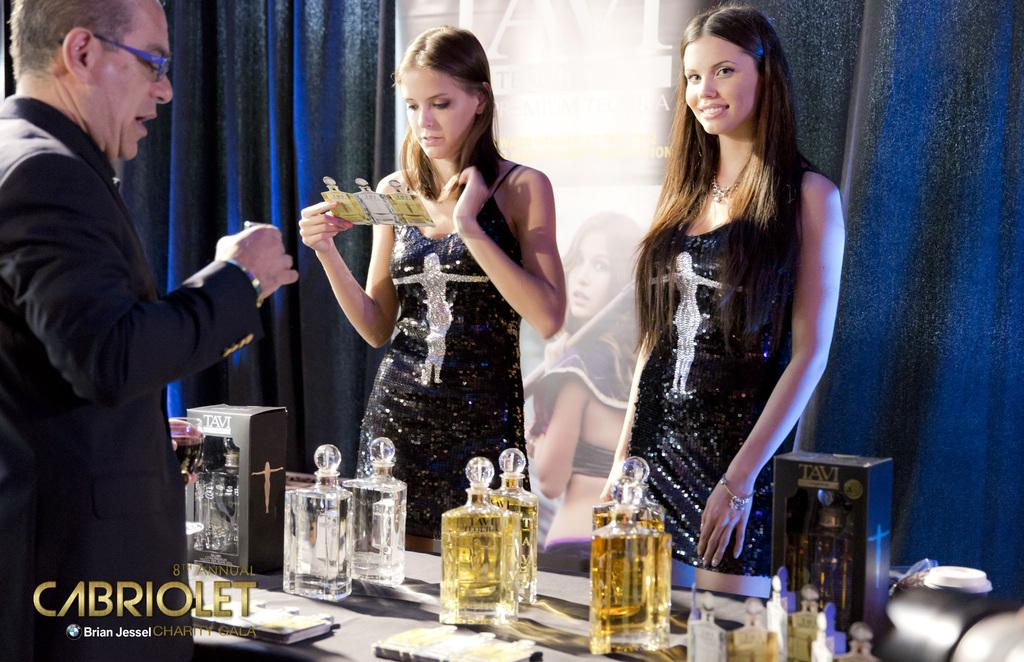Provide a one-sentence caption for the provided image. Some women serve liquor in a Cabriolet ad. 